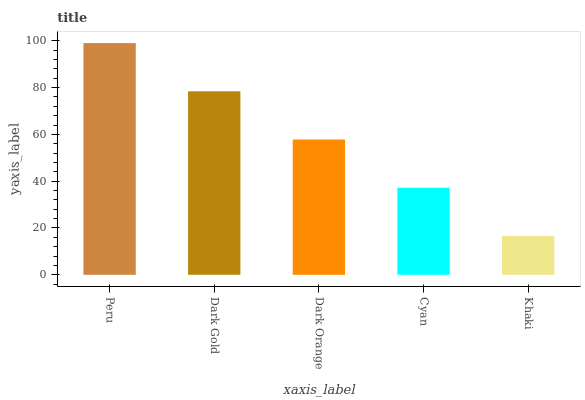Is Khaki the minimum?
Answer yes or no. Yes. Is Peru the maximum?
Answer yes or no. Yes. Is Dark Gold the minimum?
Answer yes or no. No. Is Dark Gold the maximum?
Answer yes or no. No. Is Peru greater than Dark Gold?
Answer yes or no. Yes. Is Dark Gold less than Peru?
Answer yes or no. Yes. Is Dark Gold greater than Peru?
Answer yes or no. No. Is Peru less than Dark Gold?
Answer yes or no. No. Is Dark Orange the high median?
Answer yes or no. Yes. Is Dark Orange the low median?
Answer yes or no. Yes. Is Khaki the high median?
Answer yes or no. No. Is Dark Gold the low median?
Answer yes or no. No. 